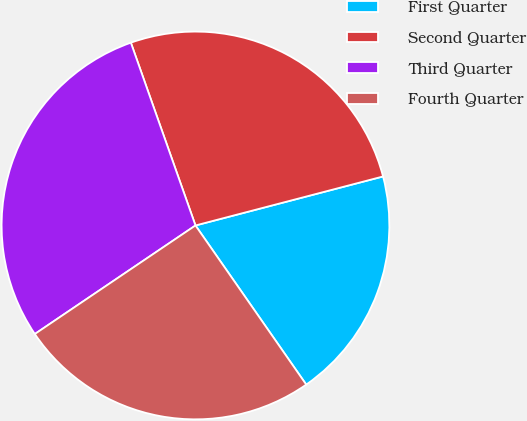Convert chart to OTSL. <chart><loc_0><loc_0><loc_500><loc_500><pie_chart><fcel>First Quarter<fcel>Second Quarter<fcel>Third Quarter<fcel>Fourth Quarter<nl><fcel>19.39%<fcel>26.34%<fcel>29.05%<fcel>25.22%<nl></chart> 